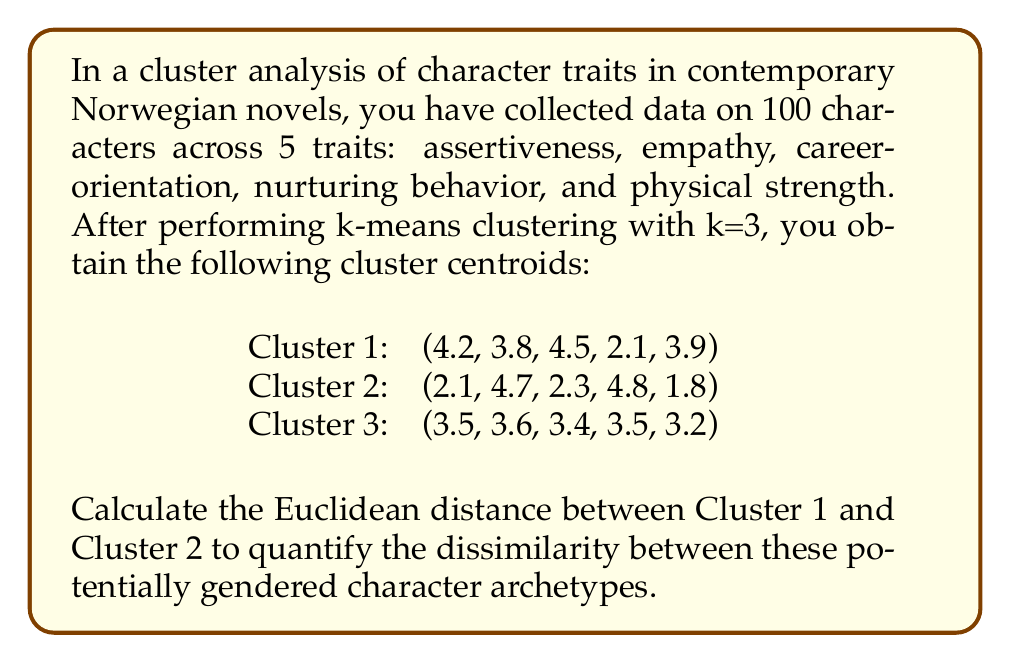Solve this math problem. To solve this problem, we need to calculate the Euclidean distance between two points in 5-dimensional space. The Euclidean distance is given by the square root of the sum of squared differences between corresponding coordinates.

Let's denote Cluster 1 as $A(a_1, a_2, a_3, a_4, a_5)$ and Cluster 2 as $B(b_1, b_2, b_3, b_4, b_5)$.

The formula for Euclidean distance in 5-dimensional space is:

$$d = \sqrt{(a_1-b_1)^2 + (a_2-b_2)^2 + (a_3-b_3)^2 + (a_4-b_4)^2 + (a_5-b_5)^2}$$

Let's calculate each term:

1. $(a_1-b_1)^2 = (4.2-2.1)^2 = 2.1^2 = 4.41$
2. $(a_2-b_2)^2 = (3.8-4.7)^2 = (-0.9)^2 = 0.81$
3. $(a_3-b_3)^2 = (4.5-2.3)^2 = 2.2^2 = 4.84$
4. $(a_4-b_4)^2 = (2.1-4.8)^2 = (-2.7)^2 = 7.29$
5. $(a_5-b_5)^2 = (3.9-1.8)^2 = 2.1^2 = 4.41$

Now, sum these terms:

$$4.41 + 0.81 + 4.84 + 7.29 + 4.41 = 21.76$$

Finally, take the square root:

$$d = \sqrt{21.76} = 4.66$$

This distance quantifies the dissimilarity between the two character archetypes represented by Clusters 1 and 2.
Answer: The Euclidean distance between Cluster 1 and Cluster 2 is approximately 4.66. 